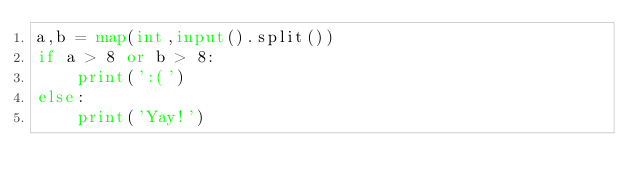<code> <loc_0><loc_0><loc_500><loc_500><_Python_>a,b = map(int,input().split())
if a > 8 or b > 8:
    print(':(')
else:
    print('Yay!')</code> 